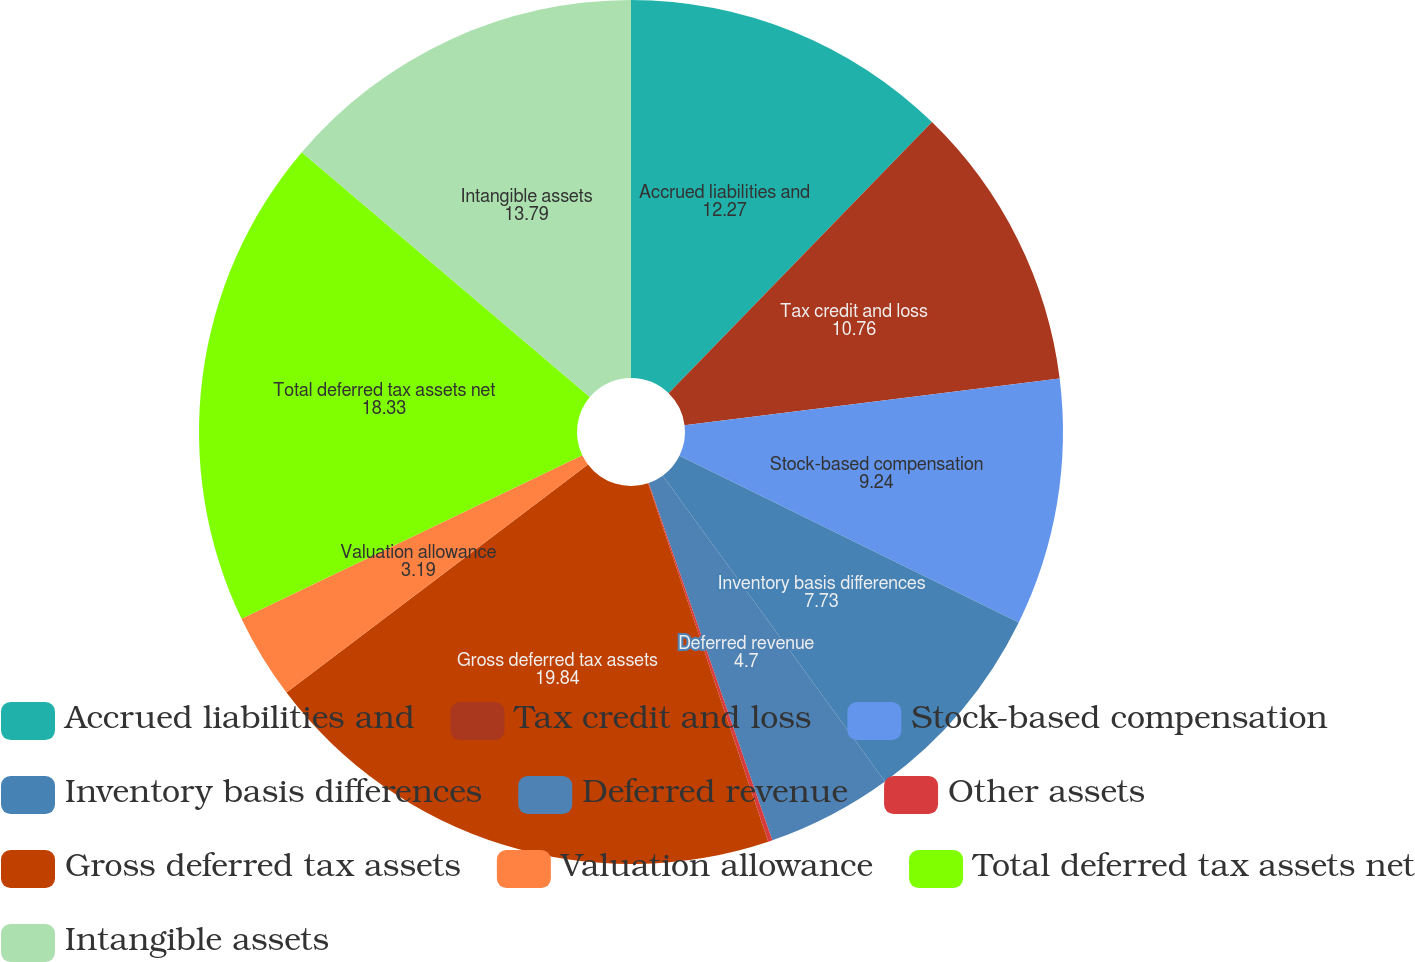Convert chart. <chart><loc_0><loc_0><loc_500><loc_500><pie_chart><fcel>Accrued liabilities and<fcel>Tax credit and loss<fcel>Stock-based compensation<fcel>Inventory basis differences<fcel>Deferred revenue<fcel>Other assets<fcel>Gross deferred tax assets<fcel>Valuation allowance<fcel>Total deferred tax assets net<fcel>Intangible assets<nl><fcel>12.27%<fcel>10.76%<fcel>9.24%<fcel>7.73%<fcel>4.7%<fcel>0.16%<fcel>19.84%<fcel>3.19%<fcel>18.33%<fcel>13.79%<nl></chart> 